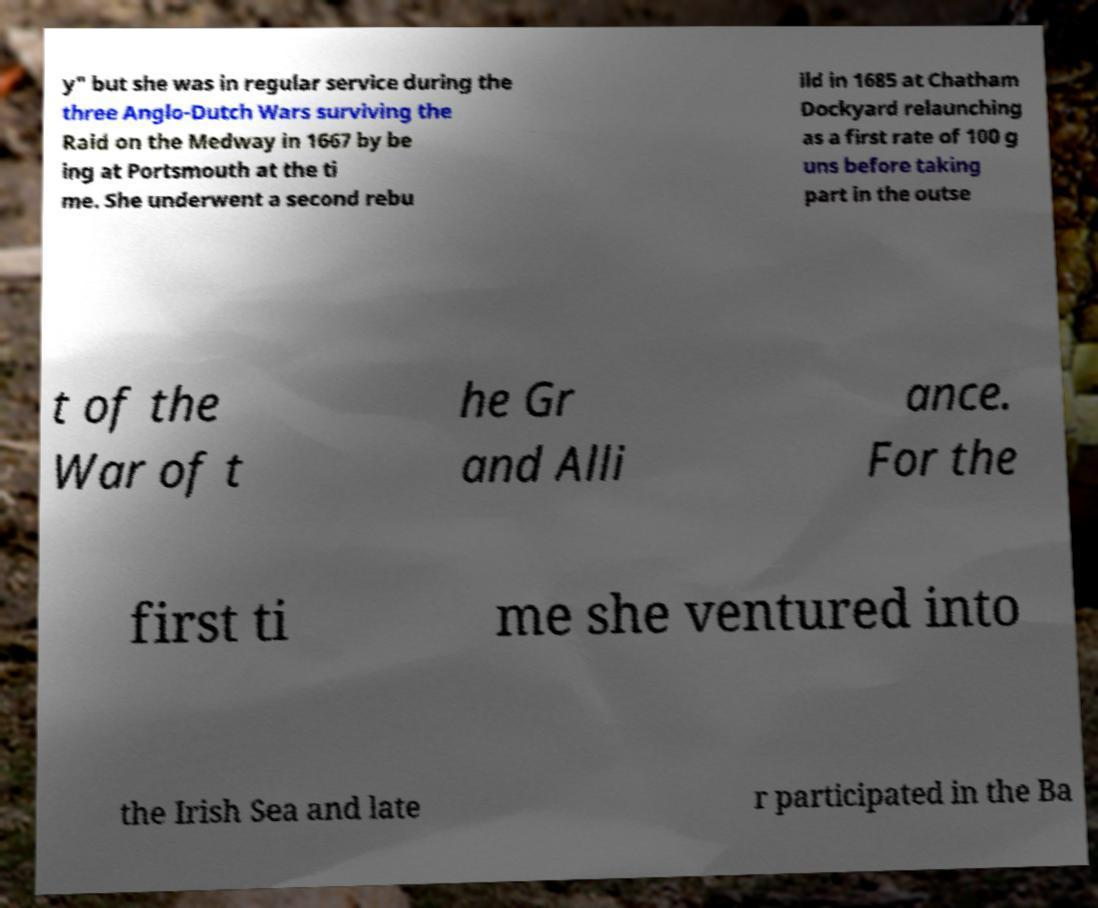There's text embedded in this image that I need extracted. Can you transcribe it verbatim? y" but she was in regular service during the three Anglo-Dutch Wars surviving the Raid on the Medway in 1667 by be ing at Portsmouth at the ti me. She underwent a second rebu ild in 1685 at Chatham Dockyard relaunching as a first rate of 100 g uns before taking part in the outse t of the War of t he Gr and Alli ance. For the first ti me she ventured into the Irish Sea and late r participated in the Ba 